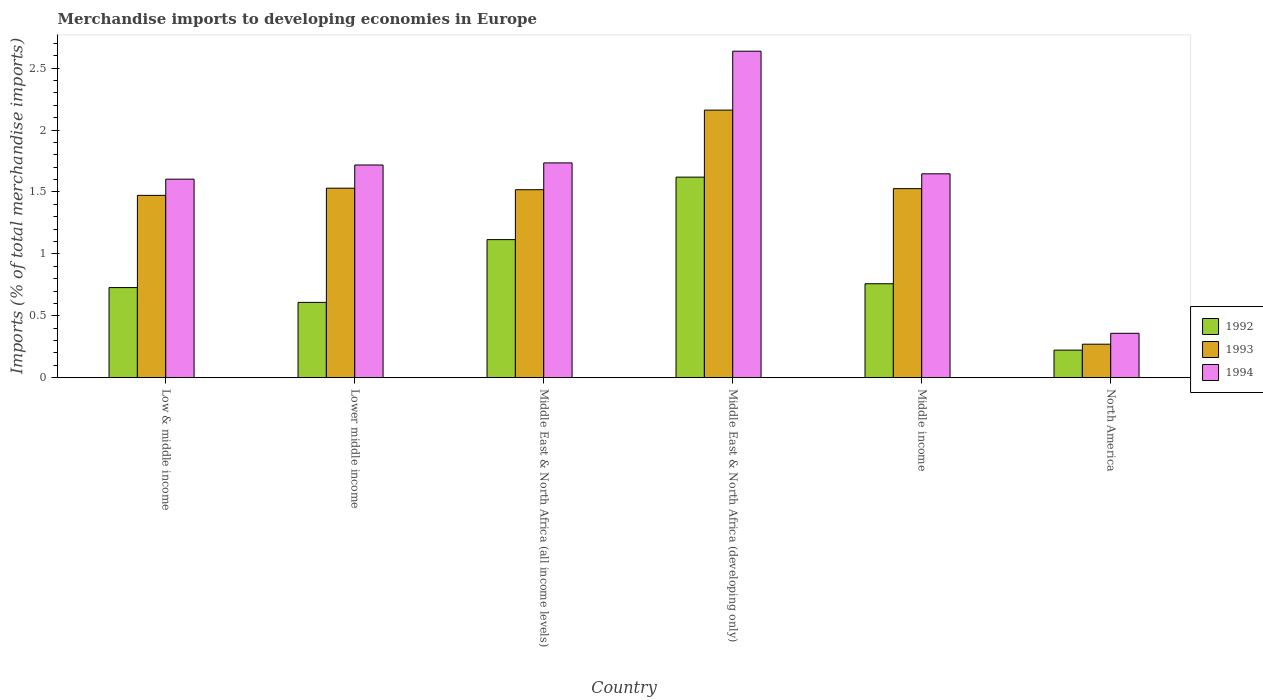How many different coloured bars are there?
Provide a succinct answer. 3. How many groups of bars are there?
Offer a terse response. 6. Are the number of bars on each tick of the X-axis equal?
Keep it short and to the point. Yes. What is the label of the 6th group of bars from the left?
Your answer should be compact. North America. In how many cases, is the number of bars for a given country not equal to the number of legend labels?
Provide a succinct answer. 0. What is the percentage total merchandise imports in 1994 in Low & middle income?
Keep it short and to the point. 1.6. Across all countries, what is the maximum percentage total merchandise imports in 1993?
Offer a terse response. 2.16. Across all countries, what is the minimum percentage total merchandise imports in 1994?
Provide a succinct answer. 0.36. In which country was the percentage total merchandise imports in 1993 maximum?
Your answer should be compact. Middle East & North Africa (developing only). In which country was the percentage total merchandise imports in 1992 minimum?
Provide a short and direct response. North America. What is the total percentage total merchandise imports in 1993 in the graph?
Your answer should be compact. 8.48. What is the difference between the percentage total merchandise imports in 1994 in Lower middle income and that in Middle East & North Africa (developing only)?
Your response must be concise. -0.92. What is the difference between the percentage total merchandise imports in 1994 in Middle East & North Africa (all income levels) and the percentage total merchandise imports in 1992 in Middle East & North Africa (developing only)?
Offer a terse response. 0.12. What is the average percentage total merchandise imports in 1994 per country?
Offer a very short reply. 1.62. What is the difference between the percentage total merchandise imports of/in 1993 and percentage total merchandise imports of/in 1992 in Middle East & North Africa (developing only)?
Provide a short and direct response. 0.54. In how many countries, is the percentage total merchandise imports in 1992 greater than 2 %?
Provide a succinct answer. 0. What is the ratio of the percentage total merchandise imports in 1993 in Lower middle income to that in Middle East & North Africa (all income levels)?
Your answer should be compact. 1.01. What is the difference between the highest and the second highest percentage total merchandise imports in 1994?
Ensure brevity in your answer.  -0.9. What is the difference between the highest and the lowest percentage total merchandise imports in 1994?
Your answer should be compact. 2.28. Is the sum of the percentage total merchandise imports in 1993 in Low & middle income and Middle income greater than the maximum percentage total merchandise imports in 1994 across all countries?
Provide a short and direct response. Yes. Are all the bars in the graph horizontal?
Your answer should be very brief. No. How many countries are there in the graph?
Offer a terse response. 6. What is the difference between two consecutive major ticks on the Y-axis?
Your answer should be very brief. 0.5. Are the values on the major ticks of Y-axis written in scientific E-notation?
Your answer should be compact. No. Does the graph contain grids?
Ensure brevity in your answer.  No. How many legend labels are there?
Ensure brevity in your answer.  3. How are the legend labels stacked?
Your answer should be compact. Vertical. What is the title of the graph?
Provide a short and direct response. Merchandise imports to developing economies in Europe. What is the label or title of the X-axis?
Provide a succinct answer. Country. What is the label or title of the Y-axis?
Provide a short and direct response. Imports (% of total merchandise imports). What is the Imports (% of total merchandise imports) in 1992 in Low & middle income?
Offer a very short reply. 0.73. What is the Imports (% of total merchandise imports) in 1993 in Low & middle income?
Keep it short and to the point. 1.47. What is the Imports (% of total merchandise imports) in 1994 in Low & middle income?
Make the answer very short. 1.6. What is the Imports (% of total merchandise imports) in 1992 in Lower middle income?
Give a very brief answer. 0.61. What is the Imports (% of total merchandise imports) in 1993 in Lower middle income?
Make the answer very short. 1.53. What is the Imports (% of total merchandise imports) of 1994 in Lower middle income?
Keep it short and to the point. 1.72. What is the Imports (% of total merchandise imports) in 1992 in Middle East & North Africa (all income levels)?
Make the answer very short. 1.12. What is the Imports (% of total merchandise imports) of 1993 in Middle East & North Africa (all income levels)?
Offer a very short reply. 1.52. What is the Imports (% of total merchandise imports) of 1994 in Middle East & North Africa (all income levels)?
Your answer should be compact. 1.74. What is the Imports (% of total merchandise imports) in 1992 in Middle East & North Africa (developing only)?
Keep it short and to the point. 1.62. What is the Imports (% of total merchandise imports) of 1993 in Middle East & North Africa (developing only)?
Your response must be concise. 2.16. What is the Imports (% of total merchandise imports) in 1994 in Middle East & North Africa (developing only)?
Provide a succinct answer. 2.64. What is the Imports (% of total merchandise imports) of 1992 in Middle income?
Ensure brevity in your answer.  0.76. What is the Imports (% of total merchandise imports) of 1993 in Middle income?
Make the answer very short. 1.53. What is the Imports (% of total merchandise imports) in 1994 in Middle income?
Offer a very short reply. 1.65. What is the Imports (% of total merchandise imports) in 1992 in North America?
Keep it short and to the point. 0.22. What is the Imports (% of total merchandise imports) of 1993 in North America?
Your response must be concise. 0.27. What is the Imports (% of total merchandise imports) of 1994 in North America?
Give a very brief answer. 0.36. Across all countries, what is the maximum Imports (% of total merchandise imports) of 1992?
Keep it short and to the point. 1.62. Across all countries, what is the maximum Imports (% of total merchandise imports) in 1993?
Your answer should be very brief. 2.16. Across all countries, what is the maximum Imports (% of total merchandise imports) in 1994?
Offer a terse response. 2.64. Across all countries, what is the minimum Imports (% of total merchandise imports) in 1992?
Give a very brief answer. 0.22. Across all countries, what is the minimum Imports (% of total merchandise imports) of 1993?
Give a very brief answer. 0.27. Across all countries, what is the minimum Imports (% of total merchandise imports) in 1994?
Offer a terse response. 0.36. What is the total Imports (% of total merchandise imports) of 1992 in the graph?
Your response must be concise. 5.05. What is the total Imports (% of total merchandise imports) in 1993 in the graph?
Offer a very short reply. 8.48. What is the total Imports (% of total merchandise imports) in 1994 in the graph?
Your response must be concise. 9.7. What is the difference between the Imports (% of total merchandise imports) in 1992 in Low & middle income and that in Lower middle income?
Keep it short and to the point. 0.12. What is the difference between the Imports (% of total merchandise imports) of 1993 in Low & middle income and that in Lower middle income?
Offer a terse response. -0.06. What is the difference between the Imports (% of total merchandise imports) of 1994 in Low & middle income and that in Lower middle income?
Provide a short and direct response. -0.11. What is the difference between the Imports (% of total merchandise imports) in 1992 in Low & middle income and that in Middle East & North Africa (all income levels)?
Your answer should be compact. -0.39. What is the difference between the Imports (% of total merchandise imports) of 1993 in Low & middle income and that in Middle East & North Africa (all income levels)?
Offer a very short reply. -0.05. What is the difference between the Imports (% of total merchandise imports) in 1994 in Low & middle income and that in Middle East & North Africa (all income levels)?
Your answer should be very brief. -0.13. What is the difference between the Imports (% of total merchandise imports) of 1992 in Low & middle income and that in Middle East & North Africa (developing only)?
Keep it short and to the point. -0.89. What is the difference between the Imports (% of total merchandise imports) of 1993 in Low & middle income and that in Middle East & North Africa (developing only)?
Provide a succinct answer. -0.69. What is the difference between the Imports (% of total merchandise imports) of 1994 in Low & middle income and that in Middle East & North Africa (developing only)?
Your answer should be very brief. -1.03. What is the difference between the Imports (% of total merchandise imports) of 1992 in Low & middle income and that in Middle income?
Offer a very short reply. -0.03. What is the difference between the Imports (% of total merchandise imports) of 1993 in Low & middle income and that in Middle income?
Your response must be concise. -0.05. What is the difference between the Imports (% of total merchandise imports) in 1994 in Low & middle income and that in Middle income?
Offer a very short reply. -0.04. What is the difference between the Imports (% of total merchandise imports) in 1992 in Low & middle income and that in North America?
Provide a short and direct response. 0.51. What is the difference between the Imports (% of total merchandise imports) in 1993 in Low & middle income and that in North America?
Keep it short and to the point. 1.2. What is the difference between the Imports (% of total merchandise imports) in 1994 in Low & middle income and that in North America?
Offer a terse response. 1.25. What is the difference between the Imports (% of total merchandise imports) in 1992 in Lower middle income and that in Middle East & North Africa (all income levels)?
Your answer should be compact. -0.51. What is the difference between the Imports (% of total merchandise imports) of 1993 in Lower middle income and that in Middle East & North Africa (all income levels)?
Give a very brief answer. 0.01. What is the difference between the Imports (% of total merchandise imports) of 1994 in Lower middle income and that in Middle East & North Africa (all income levels)?
Keep it short and to the point. -0.02. What is the difference between the Imports (% of total merchandise imports) of 1992 in Lower middle income and that in Middle East & North Africa (developing only)?
Your response must be concise. -1.01. What is the difference between the Imports (% of total merchandise imports) of 1993 in Lower middle income and that in Middle East & North Africa (developing only)?
Your answer should be compact. -0.63. What is the difference between the Imports (% of total merchandise imports) in 1994 in Lower middle income and that in Middle East & North Africa (developing only)?
Offer a terse response. -0.92. What is the difference between the Imports (% of total merchandise imports) of 1992 in Lower middle income and that in Middle income?
Your answer should be very brief. -0.15. What is the difference between the Imports (% of total merchandise imports) in 1993 in Lower middle income and that in Middle income?
Your response must be concise. 0. What is the difference between the Imports (% of total merchandise imports) of 1994 in Lower middle income and that in Middle income?
Offer a terse response. 0.07. What is the difference between the Imports (% of total merchandise imports) of 1992 in Lower middle income and that in North America?
Provide a succinct answer. 0.39. What is the difference between the Imports (% of total merchandise imports) of 1993 in Lower middle income and that in North America?
Keep it short and to the point. 1.26. What is the difference between the Imports (% of total merchandise imports) in 1994 in Lower middle income and that in North America?
Your answer should be very brief. 1.36. What is the difference between the Imports (% of total merchandise imports) of 1992 in Middle East & North Africa (all income levels) and that in Middle East & North Africa (developing only)?
Make the answer very short. -0.5. What is the difference between the Imports (% of total merchandise imports) in 1993 in Middle East & North Africa (all income levels) and that in Middle East & North Africa (developing only)?
Make the answer very short. -0.64. What is the difference between the Imports (% of total merchandise imports) of 1994 in Middle East & North Africa (all income levels) and that in Middle East & North Africa (developing only)?
Offer a very short reply. -0.9. What is the difference between the Imports (% of total merchandise imports) of 1992 in Middle East & North Africa (all income levels) and that in Middle income?
Offer a very short reply. 0.36. What is the difference between the Imports (% of total merchandise imports) of 1993 in Middle East & North Africa (all income levels) and that in Middle income?
Keep it short and to the point. -0.01. What is the difference between the Imports (% of total merchandise imports) in 1994 in Middle East & North Africa (all income levels) and that in Middle income?
Provide a succinct answer. 0.09. What is the difference between the Imports (% of total merchandise imports) in 1992 in Middle East & North Africa (all income levels) and that in North America?
Your answer should be very brief. 0.89. What is the difference between the Imports (% of total merchandise imports) of 1993 in Middle East & North Africa (all income levels) and that in North America?
Provide a short and direct response. 1.25. What is the difference between the Imports (% of total merchandise imports) of 1994 in Middle East & North Africa (all income levels) and that in North America?
Your answer should be compact. 1.38. What is the difference between the Imports (% of total merchandise imports) of 1992 in Middle East & North Africa (developing only) and that in Middle income?
Give a very brief answer. 0.86. What is the difference between the Imports (% of total merchandise imports) of 1993 in Middle East & North Africa (developing only) and that in Middle income?
Offer a terse response. 0.63. What is the difference between the Imports (% of total merchandise imports) of 1992 in Middle East & North Africa (developing only) and that in North America?
Give a very brief answer. 1.4. What is the difference between the Imports (% of total merchandise imports) in 1993 in Middle East & North Africa (developing only) and that in North America?
Offer a terse response. 1.89. What is the difference between the Imports (% of total merchandise imports) in 1994 in Middle East & North Africa (developing only) and that in North America?
Offer a terse response. 2.28. What is the difference between the Imports (% of total merchandise imports) of 1992 in Middle income and that in North America?
Make the answer very short. 0.54. What is the difference between the Imports (% of total merchandise imports) of 1993 in Middle income and that in North America?
Your response must be concise. 1.26. What is the difference between the Imports (% of total merchandise imports) in 1994 in Middle income and that in North America?
Your answer should be very brief. 1.29. What is the difference between the Imports (% of total merchandise imports) in 1992 in Low & middle income and the Imports (% of total merchandise imports) in 1993 in Lower middle income?
Ensure brevity in your answer.  -0.8. What is the difference between the Imports (% of total merchandise imports) in 1992 in Low & middle income and the Imports (% of total merchandise imports) in 1994 in Lower middle income?
Your response must be concise. -0.99. What is the difference between the Imports (% of total merchandise imports) in 1993 in Low & middle income and the Imports (% of total merchandise imports) in 1994 in Lower middle income?
Provide a succinct answer. -0.25. What is the difference between the Imports (% of total merchandise imports) in 1992 in Low & middle income and the Imports (% of total merchandise imports) in 1993 in Middle East & North Africa (all income levels)?
Ensure brevity in your answer.  -0.79. What is the difference between the Imports (% of total merchandise imports) of 1992 in Low & middle income and the Imports (% of total merchandise imports) of 1994 in Middle East & North Africa (all income levels)?
Your response must be concise. -1.01. What is the difference between the Imports (% of total merchandise imports) in 1993 in Low & middle income and the Imports (% of total merchandise imports) in 1994 in Middle East & North Africa (all income levels)?
Provide a succinct answer. -0.26. What is the difference between the Imports (% of total merchandise imports) of 1992 in Low & middle income and the Imports (% of total merchandise imports) of 1993 in Middle East & North Africa (developing only)?
Give a very brief answer. -1.43. What is the difference between the Imports (% of total merchandise imports) of 1992 in Low & middle income and the Imports (% of total merchandise imports) of 1994 in Middle East & North Africa (developing only)?
Give a very brief answer. -1.91. What is the difference between the Imports (% of total merchandise imports) of 1993 in Low & middle income and the Imports (% of total merchandise imports) of 1994 in Middle East & North Africa (developing only)?
Provide a succinct answer. -1.16. What is the difference between the Imports (% of total merchandise imports) in 1992 in Low & middle income and the Imports (% of total merchandise imports) in 1993 in Middle income?
Give a very brief answer. -0.8. What is the difference between the Imports (% of total merchandise imports) in 1992 in Low & middle income and the Imports (% of total merchandise imports) in 1994 in Middle income?
Provide a short and direct response. -0.92. What is the difference between the Imports (% of total merchandise imports) in 1993 in Low & middle income and the Imports (% of total merchandise imports) in 1994 in Middle income?
Your answer should be very brief. -0.17. What is the difference between the Imports (% of total merchandise imports) in 1992 in Low & middle income and the Imports (% of total merchandise imports) in 1993 in North America?
Ensure brevity in your answer.  0.46. What is the difference between the Imports (% of total merchandise imports) of 1992 in Low & middle income and the Imports (% of total merchandise imports) of 1994 in North America?
Keep it short and to the point. 0.37. What is the difference between the Imports (% of total merchandise imports) of 1993 in Low & middle income and the Imports (% of total merchandise imports) of 1994 in North America?
Offer a very short reply. 1.11. What is the difference between the Imports (% of total merchandise imports) in 1992 in Lower middle income and the Imports (% of total merchandise imports) in 1993 in Middle East & North Africa (all income levels)?
Keep it short and to the point. -0.91. What is the difference between the Imports (% of total merchandise imports) in 1992 in Lower middle income and the Imports (% of total merchandise imports) in 1994 in Middle East & North Africa (all income levels)?
Give a very brief answer. -1.13. What is the difference between the Imports (% of total merchandise imports) of 1993 in Lower middle income and the Imports (% of total merchandise imports) of 1994 in Middle East & North Africa (all income levels)?
Provide a short and direct response. -0.2. What is the difference between the Imports (% of total merchandise imports) in 1992 in Lower middle income and the Imports (% of total merchandise imports) in 1993 in Middle East & North Africa (developing only)?
Ensure brevity in your answer.  -1.55. What is the difference between the Imports (% of total merchandise imports) in 1992 in Lower middle income and the Imports (% of total merchandise imports) in 1994 in Middle East & North Africa (developing only)?
Ensure brevity in your answer.  -2.03. What is the difference between the Imports (% of total merchandise imports) of 1993 in Lower middle income and the Imports (% of total merchandise imports) of 1994 in Middle East & North Africa (developing only)?
Your response must be concise. -1.11. What is the difference between the Imports (% of total merchandise imports) in 1992 in Lower middle income and the Imports (% of total merchandise imports) in 1993 in Middle income?
Provide a short and direct response. -0.92. What is the difference between the Imports (% of total merchandise imports) in 1992 in Lower middle income and the Imports (% of total merchandise imports) in 1994 in Middle income?
Keep it short and to the point. -1.04. What is the difference between the Imports (% of total merchandise imports) of 1993 in Lower middle income and the Imports (% of total merchandise imports) of 1994 in Middle income?
Ensure brevity in your answer.  -0.12. What is the difference between the Imports (% of total merchandise imports) of 1992 in Lower middle income and the Imports (% of total merchandise imports) of 1993 in North America?
Ensure brevity in your answer.  0.34. What is the difference between the Imports (% of total merchandise imports) in 1992 in Lower middle income and the Imports (% of total merchandise imports) in 1994 in North America?
Your response must be concise. 0.25. What is the difference between the Imports (% of total merchandise imports) in 1993 in Lower middle income and the Imports (% of total merchandise imports) in 1994 in North America?
Provide a short and direct response. 1.17. What is the difference between the Imports (% of total merchandise imports) in 1992 in Middle East & North Africa (all income levels) and the Imports (% of total merchandise imports) in 1993 in Middle East & North Africa (developing only)?
Your answer should be compact. -1.05. What is the difference between the Imports (% of total merchandise imports) in 1992 in Middle East & North Africa (all income levels) and the Imports (% of total merchandise imports) in 1994 in Middle East & North Africa (developing only)?
Your answer should be very brief. -1.52. What is the difference between the Imports (% of total merchandise imports) of 1993 in Middle East & North Africa (all income levels) and the Imports (% of total merchandise imports) of 1994 in Middle East & North Africa (developing only)?
Make the answer very short. -1.12. What is the difference between the Imports (% of total merchandise imports) in 1992 in Middle East & North Africa (all income levels) and the Imports (% of total merchandise imports) in 1993 in Middle income?
Offer a very short reply. -0.41. What is the difference between the Imports (% of total merchandise imports) in 1992 in Middle East & North Africa (all income levels) and the Imports (% of total merchandise imports) in 1994 in Middle income?
Offer a very short reply. -0.53. What is the difference between the Imports (% of total merchandise imports) in 1993 in Middle East & North Africa (all income levels) and the Imports (% of total merchandise imports) in 1994 in Middle income?
Your answer should be very brief. -0.13. What is the difference between the Imports (% of total merchandise imports) of 1992 in Middle East & North Africa (all income levels) and the Imports (% of total merchandise imports) of 1993 in North America?
Offer a very short reply. 0.84. What is the difference between the Imports (% of total merchandise imports) of 1992 in Middle East & North Africa (all income levels) and the Imports (% of total merchandise imports) of 1994 in North America?
Offer a very short reply. 0.76. What is the difference between the Imports (% of total merchandise imports) of 1993 in Middle East & North Africa (all income levels) and the Imports (% of total merchandise imports) of 1994 in North America?
Offer a terse response. 1.16. What is the difference between the Imports (% of total merchandise imports) in 1992 in Middle East & North Africa (developing only) and the Imports (% of total merchandise imports) in 1993 in Middle income?
Your response must be concise. 0.09. What is the difference between the Imports (% of total merchandise imports) of 1992 in Middle East & North Africa (developing only) and the Imports (% of total merchandise imports) of 1994 in Middle income?
Make the answer very short. -0.03. What is the difference between the Imports (% of total merchandise imports) of 1993 in Middle East & North Africa (developing only) and the Imports (% of total merchandise imports) of 1994 in Middle income?
Your answer should be very brief. 0.51. What is the difference between the Imports (% of total merchandise imports) of 1992 in Middle East & North Africa (developing only) and the Imports (% of total merchandise imports) of 1993 in North America?
Ensure brevity in your answer.  1.35. What is the difference between the Imports (% of total merchandise imports) of 1992 in Middle East & North Africa (developing only) and the Imports (% of total merchandise imports) of 1994 in North America?
Your answer should be very brief. 1.26. What is the difference between the Imports (% of total merchandise imports) of 1993 in Middle East & North Africa (developing only) and the Imports (% of total merchandise imports) of 1994 in North America?
Your answer should be very brief. 1.8. What is the difference between the Imports (% of total merchandise imports) of 1992 in Middle income and the Imports (% of total merchandise imports) of 1993 in North America?
Provide a short and direct response. 0.49. What is the difference between the Imports (% of total merchandise imports) in 1992 in Middle income and the Imports (% of total merchandise imports) in 1994 in North America?
Your answer should be very brief. 0.4. What is the difference between the Imports (% of total merchandise imports) in 1993 in Middle income and the Imports (% of total merchandise imports) in 1994 in North America?
Ensure brevity in your answer.  1.17. What is the average Imports (% of total merchandise imports) of 1992 per country?
Offer a very short reply. 0.84. What is the average Imports (% of total merchandise imports) of 1993 per country?
Offer a terse response. 1.41. What is the average Imports (% of total merchandise imports) in 1994 per country?
Provide a succinct answer. 1.62. What is the difference between the Imports (% of total merchandise imports) in 1992 and Imports (% of total merchandise imports) in 1993 in Low & middle income?
Your answer should be very brief. -0.74. What is the difference between the Imports (% of total merchandise imports) in 1992 and Imports (% of total merchandise imports) in 1994 in Low & middle income?
Provide a succinct answer. -0.88. What is the difference between the Imports (% of total merchandise imports) of 1993 and Imports (% of total merchandise imports) of 1994 in Low & middle income?
Your answer should be compact. -0.13. What is the difference between the Imports (% of total merchandise imports) in 1992 and Imports (% of total merchandise imports) in 1993 in Lower middle income?
Offer a terse response. -0.92. What is the difference between the Imports (% of total merchandise imports) of 1992 and Imports (% of total merchandise imports) of 1994 in Lower middle income?
Keep it short and to the point. -1.11. What is the difference between the Imports (% of total merchandise imports) in 1993 and Imports (% of total merchandise imports) in 1994 in Lower middle income?
Your response must be concise. -0.19. What is the difference between the Imports (% of total merchandise imports) in 1992 and Imports (% of total merchandise imports) in 1993 in Middle East & North Africa (all income levels)?
Offer a very short reply. -0.4. What is the difference between the Imports (% of total merchandise imports) in 1992 and Imports (% of total merchandise imports) in 1994 in Middle East & North Africa (all income levels)?
Give a very brief answer. -0.62. What is the difference between the Imports (% of total merchandise imports) of 1993 and Imports (% of total merchandise imports) of 1994 in Middle East & North Africa (all income levels)?
Offer a terse response. -0.22. What is the difference between the Imports (% of total merchandise imports) of 1992 and Imports (% of total merchandise imports) of 1993 in Middle East & North Africa (developing only)?
Offer a terse response. -0.54. What is the difference between the Imports (% of total merchandise imports) in 1992 and Imports (% of total merchandise imports) in 1994 in Middle East & North Africa (developing only)?
Provide a short and direct response. -1.02. What is the difference between the Imports (% of total merchandise imports) in 1993 and Imports (% of total merchandise imports) in 1994 in Middle East & North Africa (developing only)?
Offer a terse response. -0.48. What is the difference between the Imports (% of total merchandise imports) in 1992 and Imports (% of total merchandise imports) in 1993 in Middle income?
Keep it short and to the point. -0.77. What is the difference between the Imports (% of total merchandise imports) of 1992 and Imports (% of total merchandise imports) of 1994 in Middle income?
Make the answer very short. -0.89. What is the difference between the Imports (% of total merchandise imports) of 1993 and Imports (% of total merchandise imports) of 1994 in Middle income?
Your answer should be compact. -0.12. What is the difference between the Imports (% of total merchandise imports) of 1992 and Imports (% of total merchandise imports) of 1993 in North America?
Ensure brevity in your answer.  -0.05. What is the difference between the Imports (% of total merchandise imports) in 1992 and Imports (% of total merchandise imports) in 1994 in North America?
Provide a short and direct response. -0.14. What is the difference between the Imports (% of total merchandise imports) of 1993 and Imports (% of total merchandise imports) of 1994 in North America?
Offer a terse response. -0.09. What is the ratio of the Imports (% of total merchandise imports) in 1992 in Low & middle income to that in Lower middle income?
Provide a succinct answer. 1.2. What is the ratio of the Imports (% of total merchandise imports) of 1993 in Low & middle income to that in Lower middle income?
Give a very brief answer. 0.96. What is the ratio of the Imports (% of total merchandise imports) of 1994 in Low & middle income to that in Lower middle income?
Ensure brevity in your answer.  0.93. What is the ratio of the Imports (% of total merchandise imports) of 1992 in Low & middle income to that in Middle East & North Africa (all income levels)?
Provide a short and direct response. 0.65. What is the ratio of the Imports (% of total merchandise imports) of 1993 in Low & middle income to that in Middle East & North Africa (all income levels)?
Offer a very short reply. 0.97. What is the ratio of the Imports (% of total merchandise imports) of 1994 in Low & middle income to that in Middle East & North Africa (all income levels)?
Offer a terse response. 0.92. What is the ratio of the Imports (% of total merchandise imports) of 1992 in Low & middle income to that in Middle East & North Africa (developing only)?
Your response must be concise. 0.45. What is the ratio of the Imports (% of total merchandise imports) of 1993 in Low & middle income to that in Middle East & North Africa (developing only)?
Make the answer very short. 0.68. What is the ratio of the Imports (% of total merchandise imports) in 1994 in Low & middle income to that in Middle East & North Africa (developing only)?
Offer a very short reply. 0.61. What is the ratio of the Imports (% of total merchandise imports) in 1993 in Low & middle income to that in Middle income?
Offer a terse response. 0.96. What is the ratio of the Imports (% of total merchandise imports) of 1994 in Low & middle income to that in Middle income?
Make the answer very short. 0.97. What is the ratio of the Imports (% of total merchandise imports) of 1992 in Low & middle income to that in North America?
Keep it short and to the point. 3.27. What is the ratio of the Imports (% of total merchandise imports) of 1993 in Low & middle income to that in North America?
Provide a succinct answer. 5.45. What is the ratio of the Imports (% of total merchandise imports) in 1994 in Low & middle income to that in North America?
Ensure brevity in your answer.  4.48. What is the ratio of the Imports (% of total merchandise imports) of 1992 in Lower middle income to that in Middle East & North Africa (all income levels)?
Offer a very short reply. 0.55. What is the ratio of the Imports (% of total merchandise imports) in 1993 in Lower middle income to that in Middle East & North Africa (all income levels)?
Offer a very short reply. 1.01. What is the ratio of the Imports (% of total merchandise imports) in 1994 in Lower middle income to that in Middle East & North Africa (all income levels)?
Provide a short and direct response. 0.99. What is the ratio of the Imports (% of total merchandise imports) in 1992 in Lower middle income to that in Middle East & North Africa (developing only)?
Ensure brevity in your answer.  0.38. What is the ratio of the Imports (% of total merchandise imports) in 1993 in Lower middle income to that in Middle East & North Africa (developing only)?
Your response must be concise. 0.71. What is the ratio of the Imports (% of total merchandise imports) of 1994 in Lower middle income to that in Middle East & North Africa (developing only)?
Provide a succinct answer. 0.65. What is the ratio of the Imports (% of total merchandise imports) in 1992 in Lower middle income to that in Middle income?
Give a very brief answer. 0.8. What is the ratio of the Imports (% of total merchandise imports) of 1994 in Lower middle income to that in Middle income?
Ensure brevity in your answer.  1.04. What is the ratio of the Imports (% of total merchandise imports) in 1992 in Lower middle income to that in North America?
Provide a short and direct response. 2.73. What is the ratio of the Imports (% of total merchandise imports) of 1993 in Lower middle income to that in North America?
Keep it short and to the point. 5.66. What is the ratio of the Imports (% of total merchandise imports) of 1994 in Lower middle income to that in North America?
Keep it short and to the point. 4.79. What is the ratio of the Imports (% of total merchandise imports) in 1992 in Middle East & North Africa (all income levels) to that in Middle East & North Africa (developing only)?
Offer a very short reply. 0.69. What is the ratio of the Imports (% of total merchandise imports) in 1993 in Middle East & North Africa (all income levels) to that in Middle East & North Africa (developing only)?
Offer a terse response. 0.7. What is the ratio of the Imports (% of total merchandise imports) of 1994 in Middle East & North Africa (all income levels) to that in Middle East & North Africa (developing only)?
Ensure brevity in your answer.  0.66. What is the ratio of the Imports (% of total merchandise imports) of 1992 in Middle East & North Africa (all income levels) to that in Middle income?
Give a very brief answer. 1.47. What is the ratio of the Imports (% of total merchandise imports) of 1993 in Middle East & North Africa (all income levels) to that in Middle income?
Provide a short and direct response. 0.99. What is the ratio of the Imports (% of total merchandise imports) of 1994 in Middle East & North Africa (all income levels) to that in Middle income?
Your answer should be compact. 1.05. What is the ratio of the Imports (% of total merchandise imports) of 1992 in Middle East & North Africa (all income levels) to that in North America?
Make the answer very short. 5.01. What is the ratio of the Imports (% of total merchandise imports) in 1993 in Middle East & North Africa (all income levels) to that in North America?
Offer a terse response. 5.62. What is the ratio of the Imports (% of total merchandise imports) of 1994 in Middle East & North Africa (all income levels) to that in North America?
Give a very brief answer. 4.84. What is the ratio of the Imports (% of total merchandise imports) in 1992 in Middle East & North Africa (developing only) to that in Middle income?
Give a very brief answer. 2.14. What is the ratio of the Imports (% of total merchandise imports) of 1993 in Middle East & North Africa (developing only) to that in Middle income?
Your response must be concise. 1.42. What is the ratio of the Imports (% of total merchandise imports) in 1994 in Middle East & North Africa (developing only) to that in Middle income?
Keep it short and to the point. 1.6. What is the ratio of the Imports (% of total merchandise imports) in 1992 in Middle East & North Africa (developing only) to that in North America?
Offer a terse response. 7.28. What is the ratio of the Imports (% of total merchandise imports) of 1993 in Middle East & North Africa (developing only) to that in North America?
Give a very brief answer. 8. What is the ratio of the Imports (% of total merchandise imports) in 1994 in Middle East & North Africa (developing only) to that in North America?
Offer a terse response. 7.36. What is the ratio of the Imports (% of total merchandise imports) of 1992 in Middle income to that in North America?
Offer a very short reply. 3.41. What is the ratio of the Imports (% of total merchandise imports) of 1993 in Middle income to that in North America?
Provide a short and direct response. 5.65. What is the ratio of the Imports (% of total merchandise imports) in 1994 in Middle income to that in North America?
Your answer should be compact. 4.6. What is the difference between the highest and the second highest Imports (% of total merchandise imports) of 1992?
Provide a short and direct response. 0.5. What is the difference between the highest and the second highest Imports (% of total merchandise imports) of 1993?
Ensure brevity in your answer.  0.63. What is the difference between the highest and the second highest Imports (% of total merchandise imports) of 1994?
Provide a succinct answer. 0.9. What is the difference between the highest and the lowest Imports (% of total merchandise imports) of 1992?
Your answer should be very brief. 1.4. What is the difference between the highest and the lowest Imports (% of total merchandise imports) in 1993?
Provide a short and direct response. 1.89. What is the difference between the highest and the lowest Imports (% of total merchandise imports) in 1994?
Offer a terse response. 2.28. 